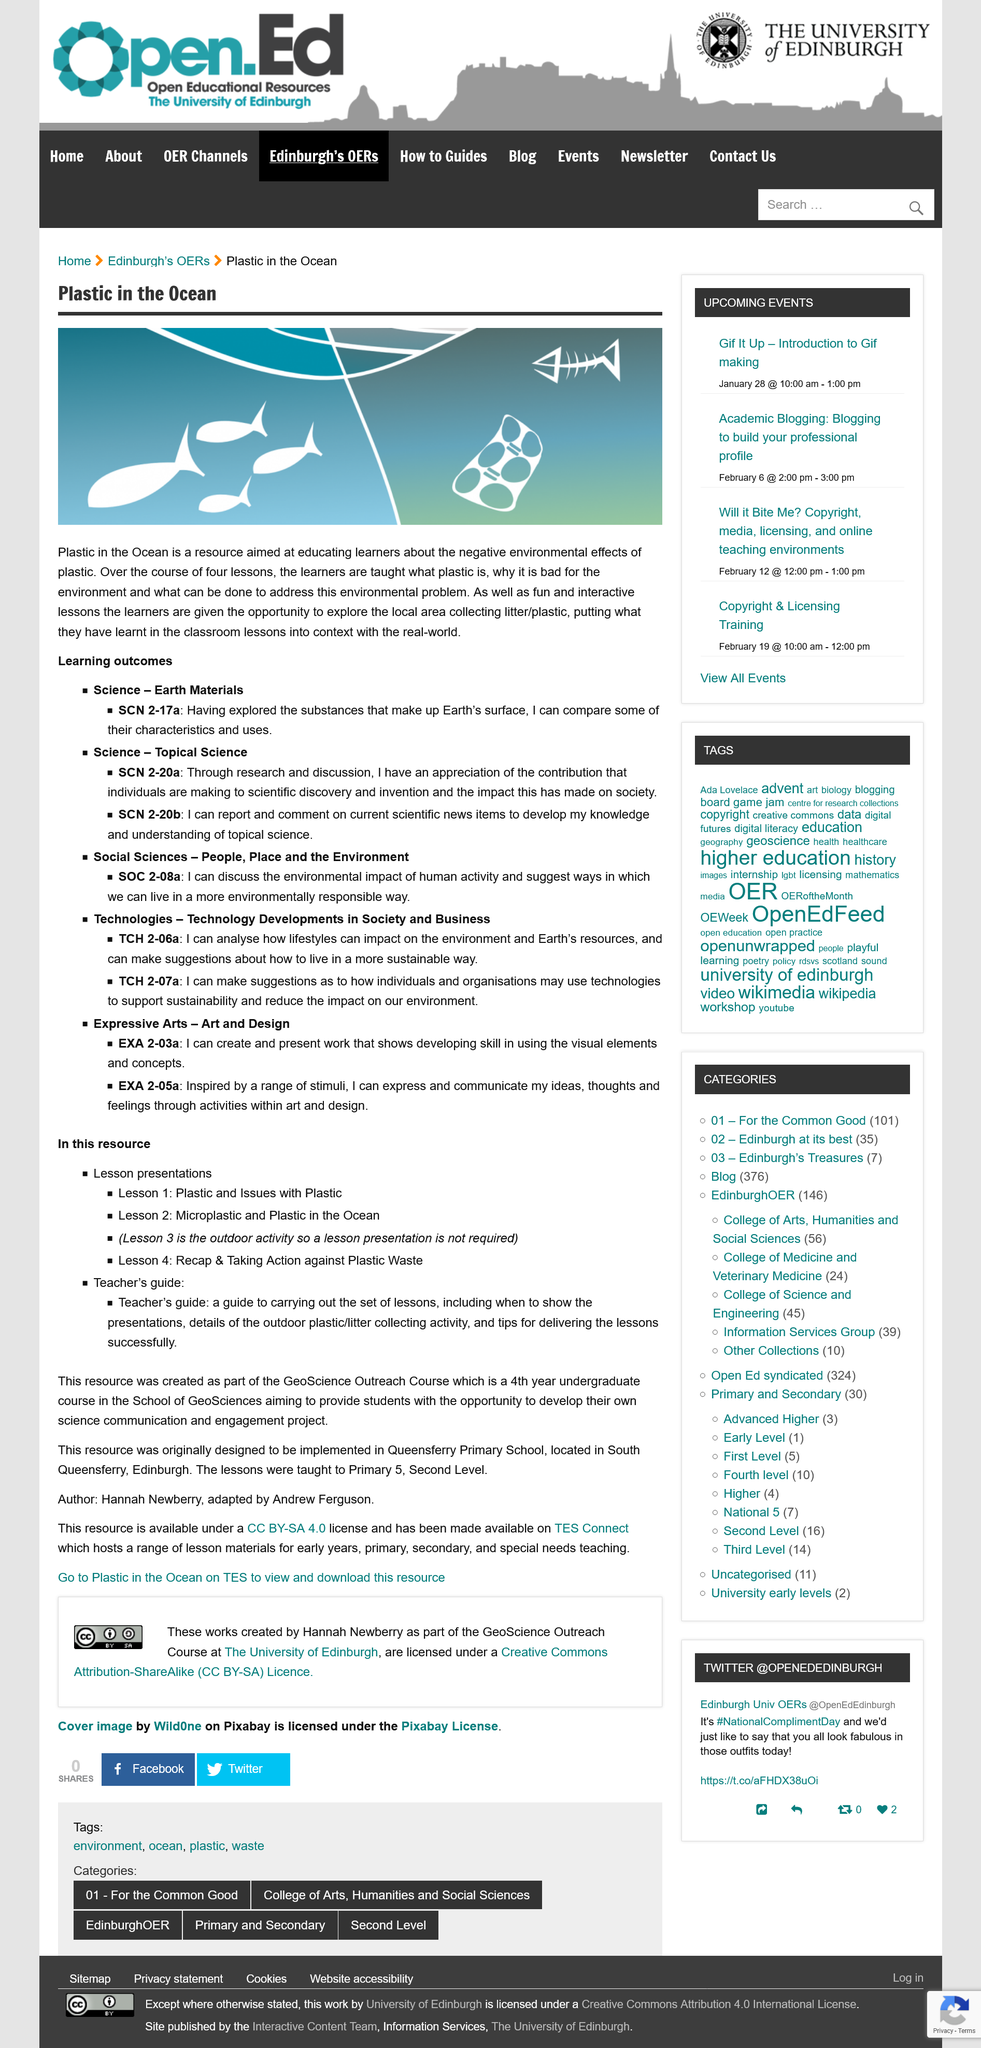Indicate a few pertinent items in this graphic. Yes, Topical Science is one of the Learning Outcomes in Is Science. The negative environmental effects of plastic far outweigh any potential positive impact it may have. The SCN 2-20a is classified under the category of Science — Topical Science. The resource was designed to be implemented in Queensberry Primary School by Hannah Newberry. The photo is meant to represent a body of water that is classified as an ocean. 